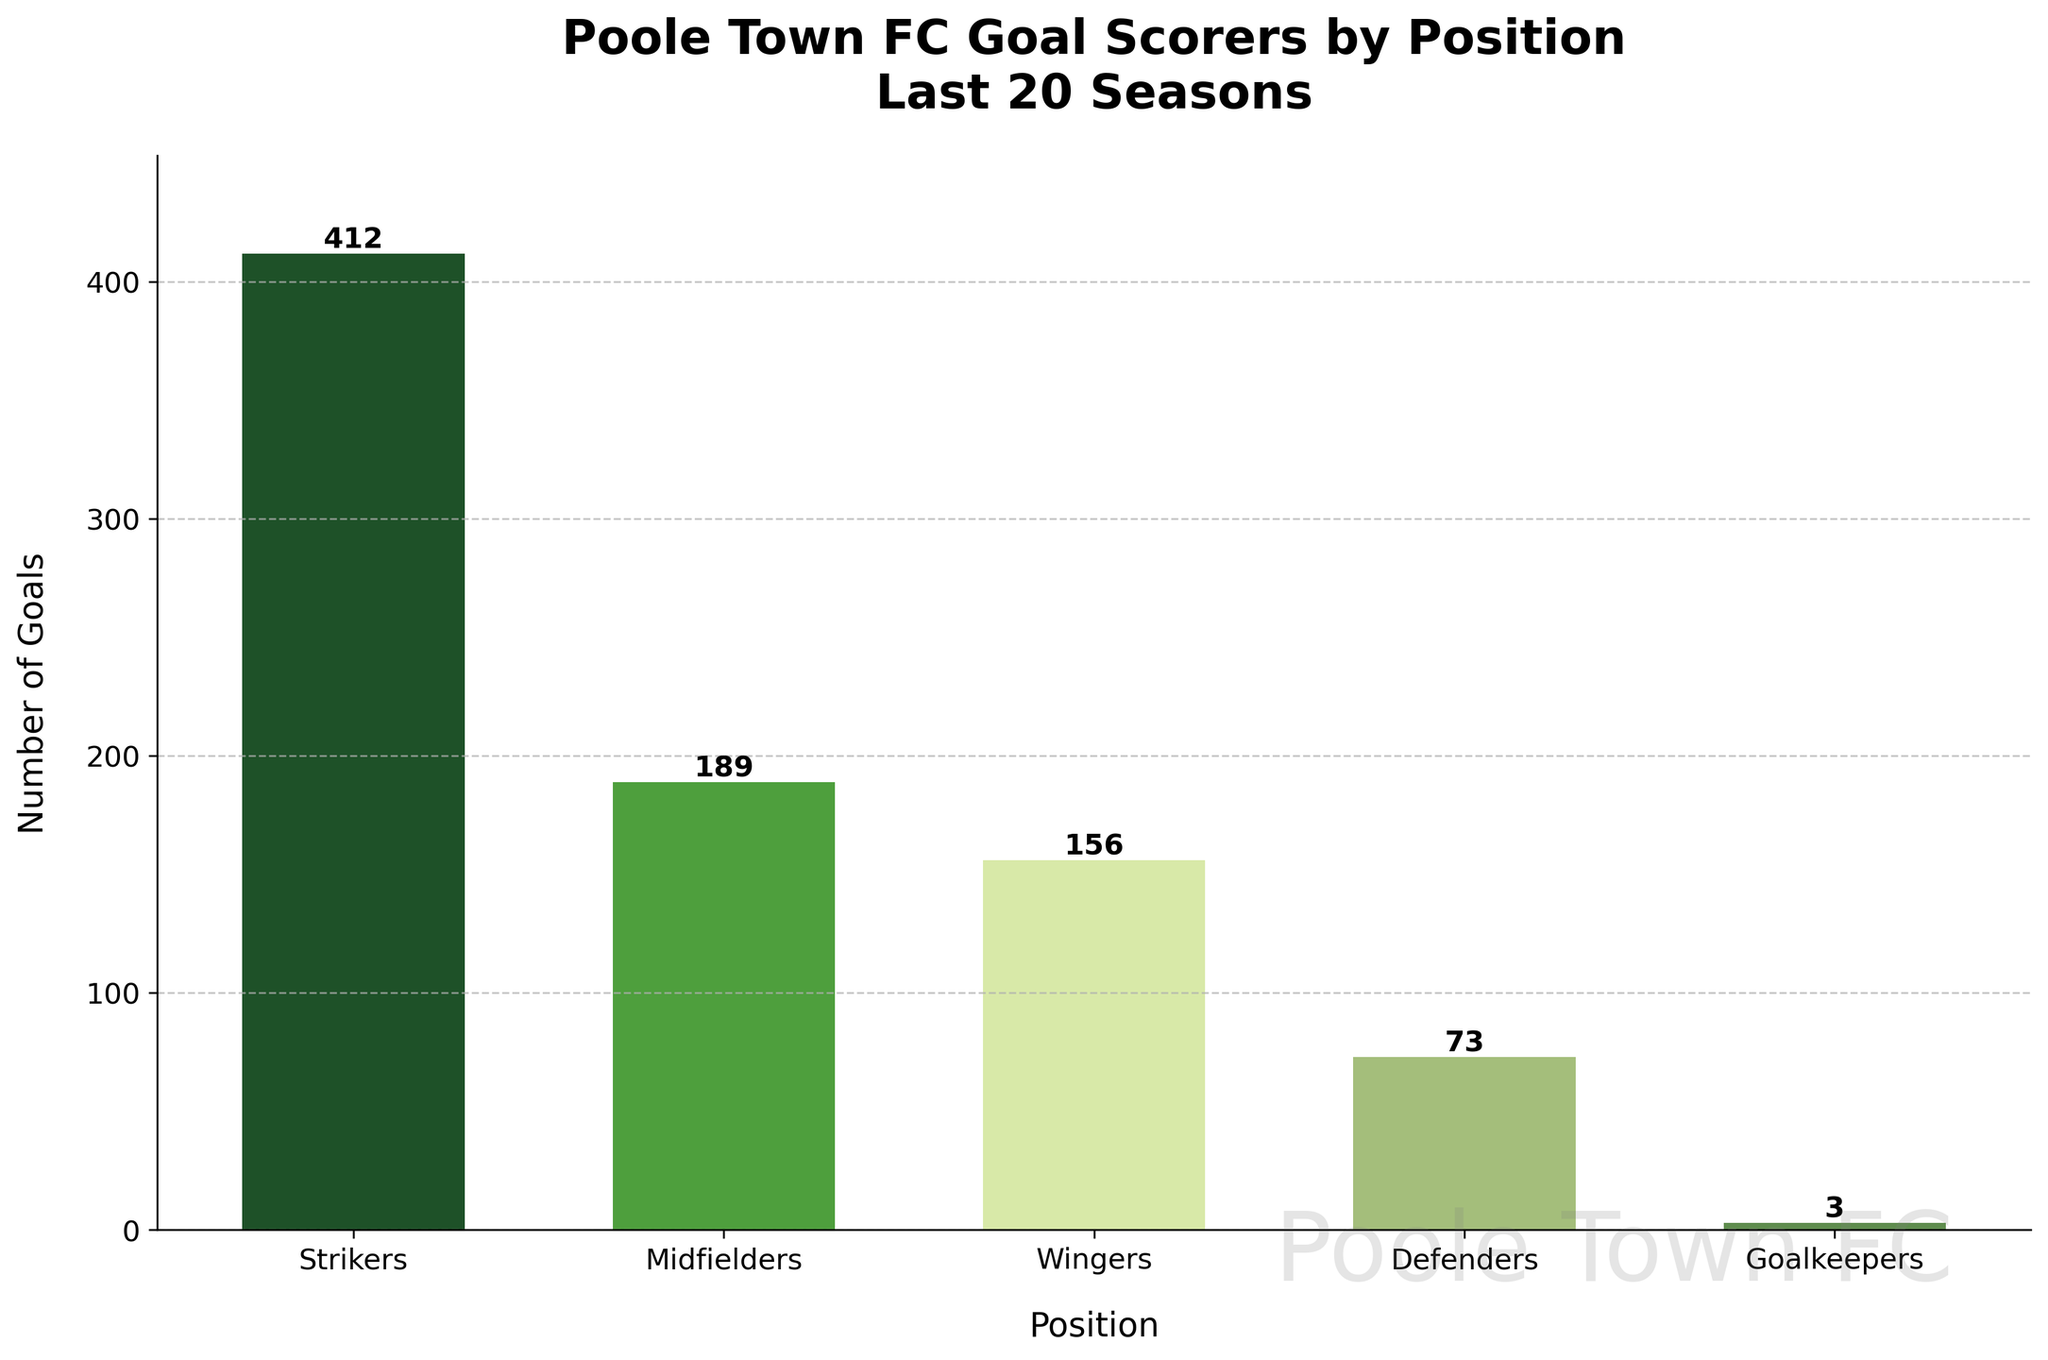What's the total number of goals scored by midfielders and wingers? To find this, add the goals scored by midfielders (189) and wingers (156). The calculation is 189 + 156 = 345.
Answer: 345 Which position has scored the fewest goals? Look at the bar representing goalkeepers. It is the shortest and has a value of 3, indicating goalkeepers scored the fewest goals.
Answer: Goalkeepers How many more goals have strikers scored compared to defenders? Subtract the goals scored by defenders (73) from those scored by strikers (412). The calculation is 412 - 73 = 339.
Answer: 339 What is the average number of goals scored by each position? To find the average, sum all the goals (412 + 189 + 156 + 73 + 3) and then divide by the number of positions (5). Calculation: (412 + 189 + 156 + 73 + 3)/5 = 166.6.
Answer: 166.6 Which positions collectively scored the most goals? Combine the goals for strikers, midfielders, and wingers. Calculation: 412 + 189 + 156 = 757, which is greater than the goals scored by defenders and goalkeepers combined (73 + 3 = 76).
Answer: Strikers, Midfielders, Wingers By how much do the goals scored by midfielders exceed the goals scored by defenders and goalkeepers combined? First, find the total goals for defenders and goalkeepers: 73 + 3 = 76. Then subtract this from the goals scored by midfielders: 189 - 76 = 113.
Answer: 113 What percentage of the total goals were scored by strikers? Sum the total goals (833), and then divide the goals scored by strikers by this total and multiply by 100. Calculation: (412/833) * 100 = 49.46%.
Answer: 49.46% How many goals are there between the highest and the second highest scoring positions? Find the difference between the goals scored by strikers (412) and midfielders (189). Calculation: 412 - 189 = 223.
Answer: 223 Which position's goals represent less than 10% of the total goals? First, calculate 10% of the total goals (833). 10% of 833 is 83.3. Both defenders (73) and goalkeepers (3) scored fewer than 83.3 goals.
Answer: Defenders, Goalkeepers What is the visual cue that indicates the player position that scored the most goals? The bar representing strikers is the tallest among all the bars, visually indicating the position that scored the most goals.
Answer: The tallest bar 